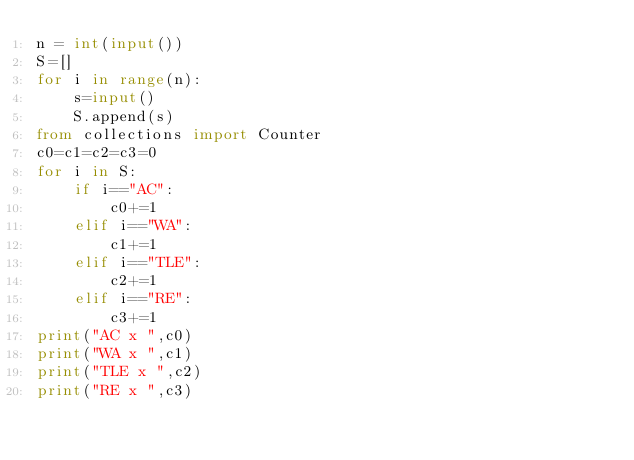Convert code to text. <code><loc_0><loc_0><loc_500><loc_500><_Python_>n = int(input())
S=[]
for i in range(n):
    s=input()
    S.append(s)
from collections import Counter
c0=c1=c2=c3=0
for i in S:
    if i=="AC":
        c0+=1
    elif i=="WA":
        c1+=1
    elif i=="TLE":
        c2+=1
    elif i=="RE":
        c3+=1
print("AC x ",c0)
print("WA x ",c1)
print("TLE x ",c2)
print("RE x ",c3)</code> 